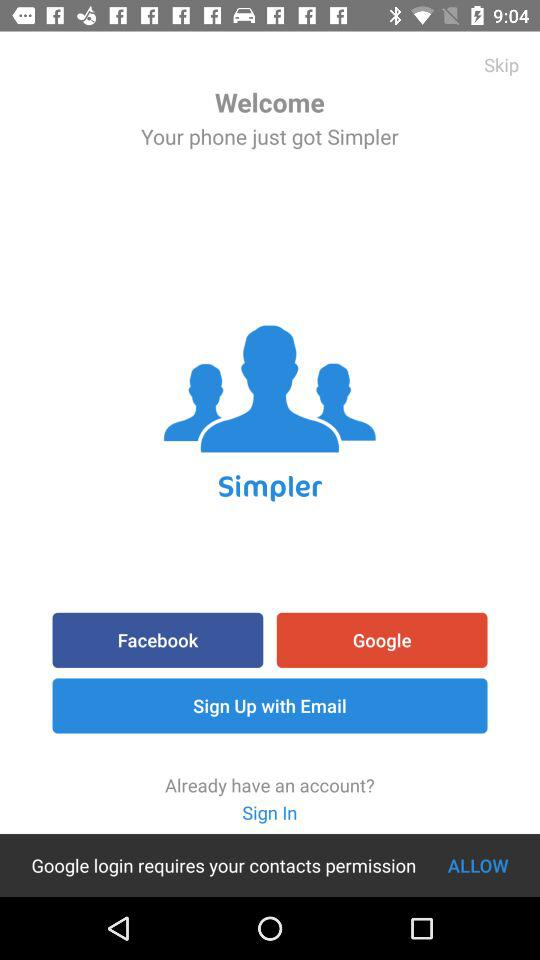What is the name of the application? The name of the application is "Simpler". 